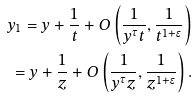<formula> <loc_0><loc_0><loc_500><loc_500>y _ { 1 } = y + \frac { 1 } { t } + O \left ( \frac { 1 } { y ^ { \tau } t } , \frac { 1 } { t ^ { 1 + \epsilon } } \right ) \\ = y + \frac { 1 } { z } + O \left ( \frac { 1 } { y ^ { \tau } z } , \frac { 1 } { z ^ { 1 + \epsilon } } \right ) . \\</formula> 